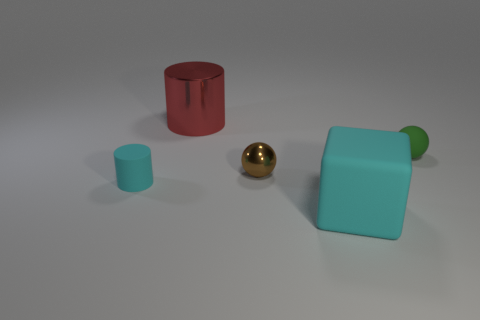Add 2 tiny brown metal objects. How many objects exist? 7 Subtract all cubes. How many objects are left? 4 Add 3 cyan matte things. How many cyan matte things are left? 5 Add 5 big spheres. How many big spheres exist? 5 Subtract 0 green blocks. How many objects are left? 5 Subtract all brown spheres. Subtract all cyan blocks. How many spheres are left? 1 Subtract all small cyan matte cylinders. Subtract all big matte cubes. How many objects are left? 3 